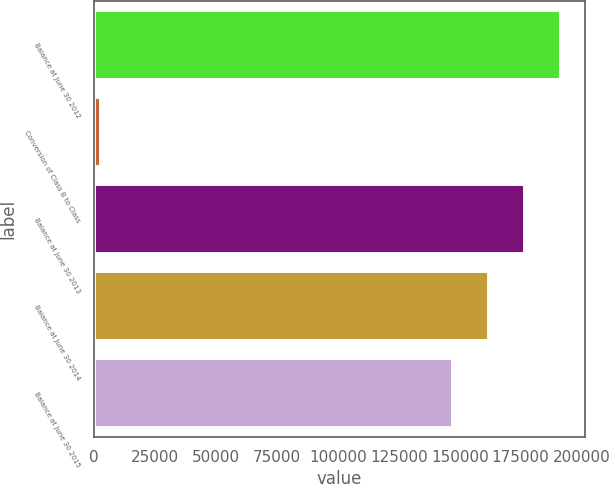Convert chart. <chart><loc_0><loc_0><loc_500><loc_500><bar_chart><fcel>Balance at June 30 2012<fcel>Conversion of Class B to Class<fcel>Balance at June 30 2013<fcel>Balance at June 30 2014<fcel>Balance at June 30 2015<nl><fcel>191740<fcel>2800<fcel>176842<fcel>161944<fcel>147046<nl></chart> 